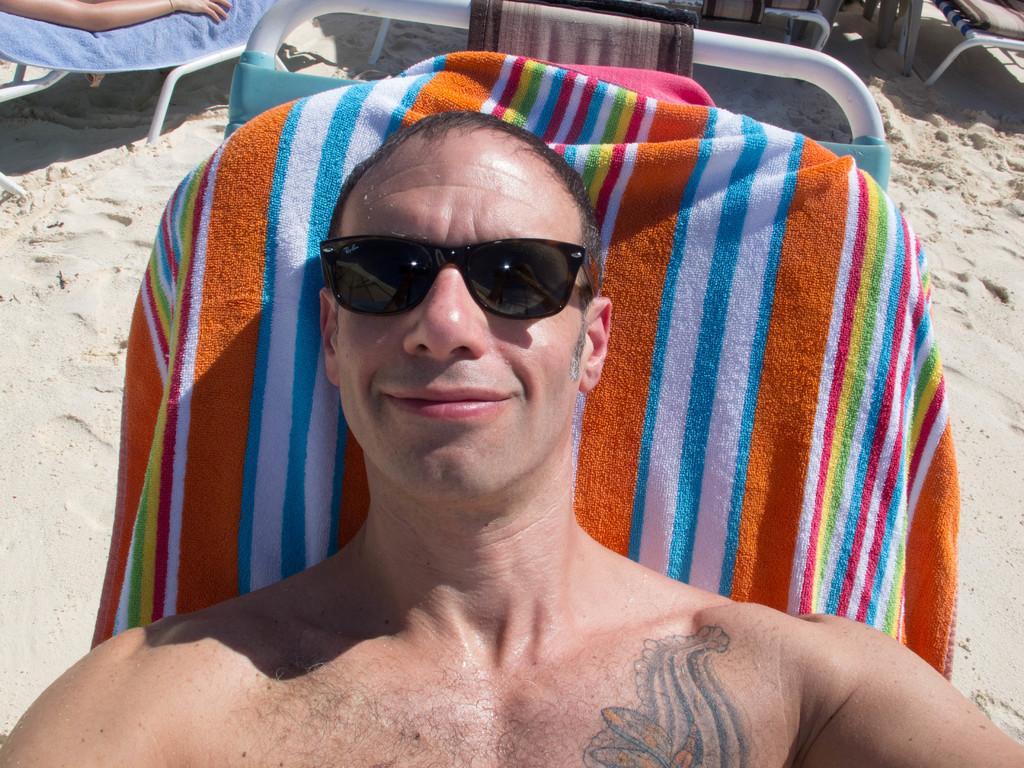Describe this image in one or two sentences. In this image, in the middle, we can see a man wearing black, color goggles is sitting on the chair. On the left side, we can also see another person. On the right side, we can also see another chair. In the background, we can see a metal rod, at the bottom, we can see a sand. 